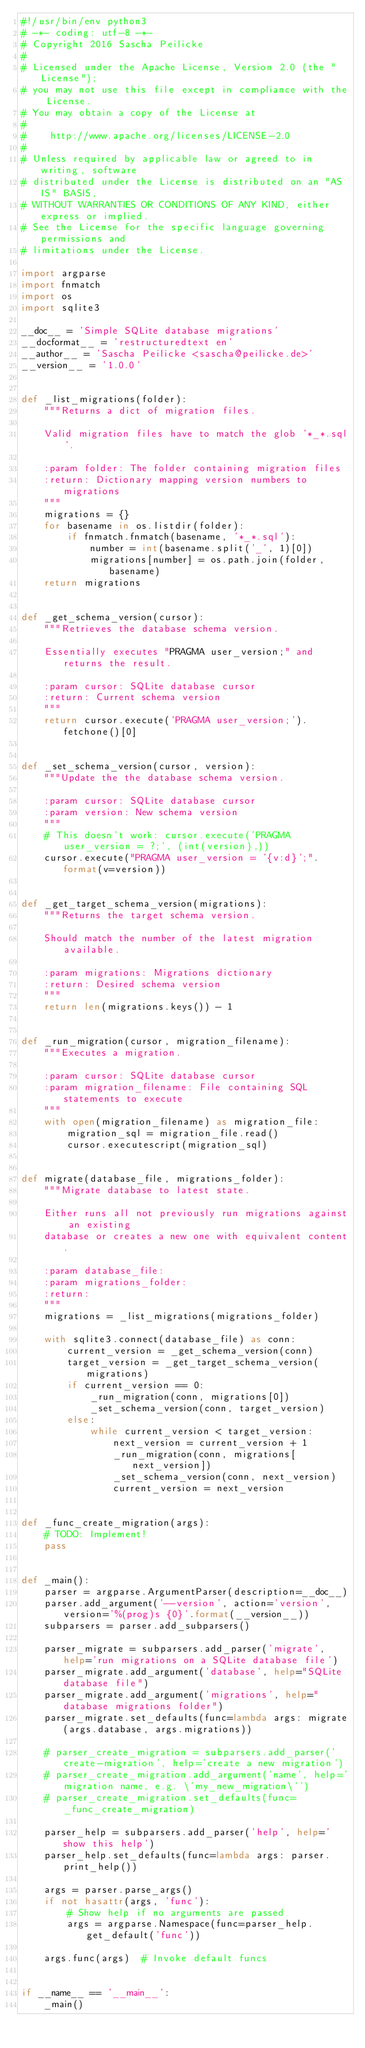Convert code to text. <code><loc_0><loc_0><loc_500><loc_500><_Python_>#!/usr/bin/env python3
# -*- coding: utf-8 -*-
# Copyright 2016 Sascha Peilicke
#
# Licensed under the Apache License, Version 2.0 (the "License");
# you may not use this file except in compliance with the License.
# You may obtain a copy of the License at
#
#    http://www.apache.org/licenses/LICENSE-2.0
#
# Unless required by applicable law or agreed to in writing, software
# distributed under the License is distributed on an "AS IS" BASIS,
# WITHOUT WARRANTIES OR CONDITIONS OF ANY KIND, either express or implied.
# See the License for the specific language governing permissions and
# limitations under the License.

import argparse
import fnmatch
import os
import sqlite3

__doc__ = 'Simple SQLite database migrations'
__docformat__ = 'restructuredtext en'
__author__ = 'Sascha Peilicke <sascha@peilicke.de>'
__version__ = '1.0.0'


def _list_migrations(folder):
    """Returns a dict of migration files.

    Valid migration files have to match the glob '*_*.sql'.

    :param folder: The folder containing migration files
    :return: Dictionary mapping version numbers to migrations
    """
    migrations = {}
    for basename in os.listdir(folder):
        if fnmatch.fnmatch(basename, '*_*.sql'):
            number = int(basename.split('_', 1)[0])
            migrations[number] = os.path.join(folder, basename)
    return migrations


def _get_schema_version(cursor):
    """Retrieves the database schema version.

    Essentially executes "PRAGMA user_version;" and returns the result.

    :param cursor: SQLite database cursor
    :return: Current schema version
    """
    return cursor.execute('PRAGMA user_version;').fetchone()[0]


def _set_schema_version(cursor, version):
    """Update the the database schema version.

    :param cursor: SQLite database cursor
    :param version: New schema version
    """
    # This doesn't work: cursor.execute('PRAGMA user_version = ?;', (int(version),))
    cursor.execute("PRAGMA user_version = '{v:d}';".format(v=version))


def _get_target_schema_version(migrations):
    """Returns the target schema version.

    Should match the number of the latest migration available.

    :param migrations: Migrations dictionary
    :return: Desired schema version
    """
    return len(migrations.keys()) - 1


def _run_migration(cursor, migration_filename):
    """Executes a migration.

    :param cursor: SQLite database cursor
    :param migration_filename: File containing SQL statements to execute
    """
    with open(migration_filename) as migration_file:
        migration_sql = migration_file.read()
        cursor.executescript(migration_sql)


def migrate(database_file, migrations_folder):
    """Migrate database to latest state.

    Either runs all not previously run migrations against an existing
    database or creates a new one with equivalent content.

    :param database_file:
    :param migrations_folder:
    :return:
    """
    migrations = _list_migrations(migrations_folder)

    with sqlite3.connect(database_file) as conn:
        current_version = _get_schema_version(conn)
        target_version = _get_target_schema_version(migrations)
        if current_version == 0:
            _run_migration(conn, migrations[0])
            _set_schema_version(conn, target_version)
        else:
            while current_version < target_version:
                next_version = current_version + 1
                _run_migration(conn, migrations[next_version])
                _set_schema_version(conn, next_version)
                current_version = next_version


def _func_create_migration(args):
    # TODO: Implement!
    pass


def _main():
    parser = argparse.ArgumentParser(description=__doc__)
    parser.add_argument('--version', action='version', version='%(prog)s {0}'.format(__version__))
    subparsers = parser.add_subparsers()

    parser_migrate = subparsers.add_parser('migrate', help='run migrations on a SQLite database file')
    parser_migrate.add_argument('database', help="SQLite database file")
    parser_migrate.add_argument('migrations', help="database migrations folder")
    parser_migrate.set_defaults(func=lambda args: migrate(args.database, args.migrations))

    # parser_create_migration = subparsers.add_parser('create-migration', help='create a new migration')
    # parser_create_migration.add_argument('name', help='migration name, e.g. \'my_new_migration\'')
    # parser_create_migration.set_defaults(func=_func_create_migration)

    parser_help = subparsers.add_parser('help', help='show this help')
    parser_help.set_defaults(func=lambda args: parser.print_help())

    args = parser.parse_args()
    if not hasattr(args, 'func'):
        # Show help if no arguments are passed
        args = argparse.Namespace(func=parser_help.get_default('func'))

    args.func(args)  # Invoke default funcs


if __name__ == '__main__':
    _main()
</code> 